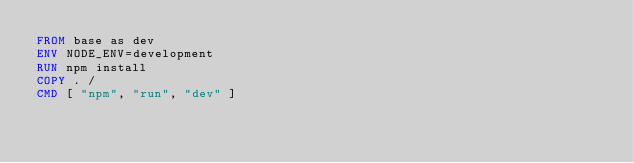Convert code to text. <code><loc_0><loc_0><loc_500><loc_500><_Dockerfile_>FROM base as dev
ENV NODE_ENV=development
RUN npm install
COPY . /
CMD [ "npm", "run", "dev" ]
</code> 